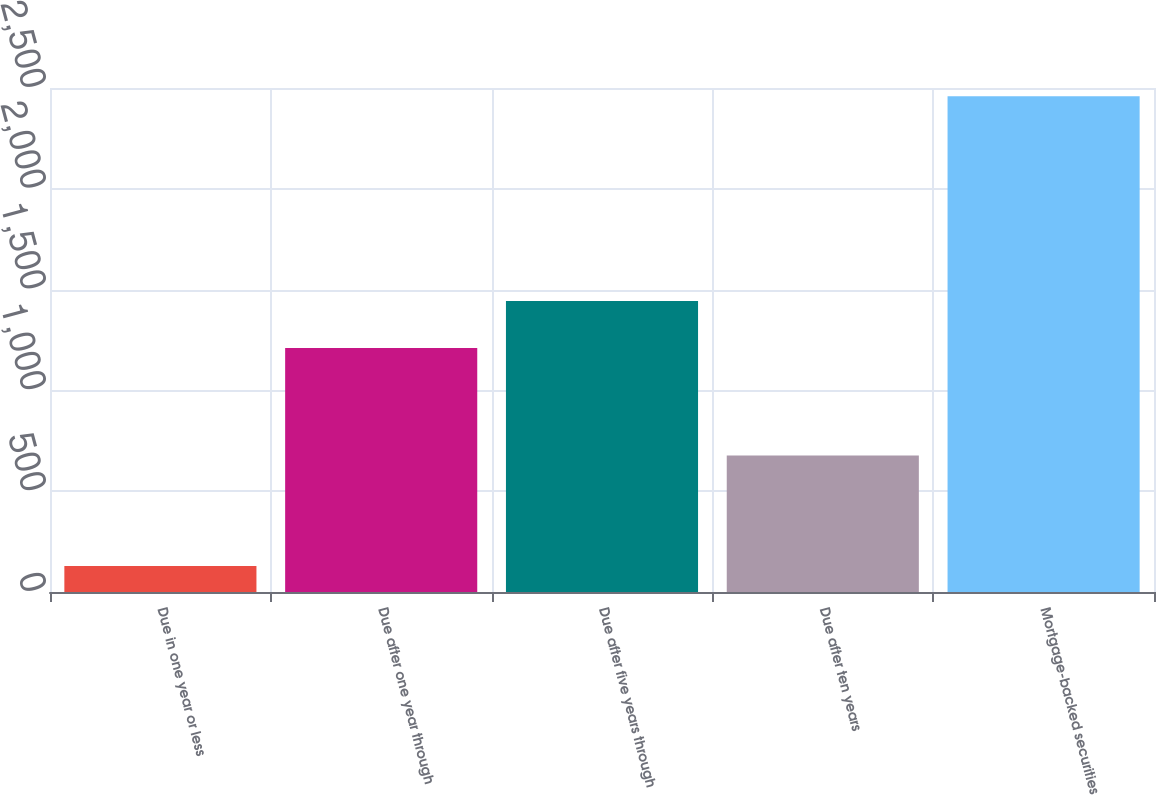Convert chart to OTSL. <chart><loc_0><loc_0><loc_500><loc_500><bar_chart><fcel>Due in one year or less<fcel>Due after one year through<fcel>Due after five years through<fcel>Due after ten years<fcel>Mortgage-backed securities<nl><fcel>129.2<fcel>1209.9<fcel>1442.87<fcel>677.7<fcel>2458.9<nl></chart> 